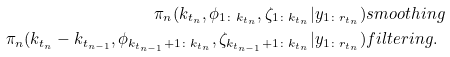<formula> <loc_0><loc_0><loc_500><loc_500>\pi _ { n } ( k _ { t _ { n } } , \phi _ { 1 \colon k _ { t _ { n } } } , \zeta _ { 1 \colon k _ { t _ { n } } } | y _ { 1 \colon r _ { t _ { n } } } ) & s m o o t h i n g \\ \pi _ { n } ( k _ { t _ { n } } - k _ { t _ { n - 1 } } , \phi _ { k _ { t _ { n - 1 } } + 1 \colon k _ { t _ { n } } } , \zeta _ { k _ { t _ { n - 1 } } + 1 \colon k _ { t _ { n } } } | y _ { 1 \colon r _ { t _ { n } } } ) & f i l t e r i n g .</formula> 